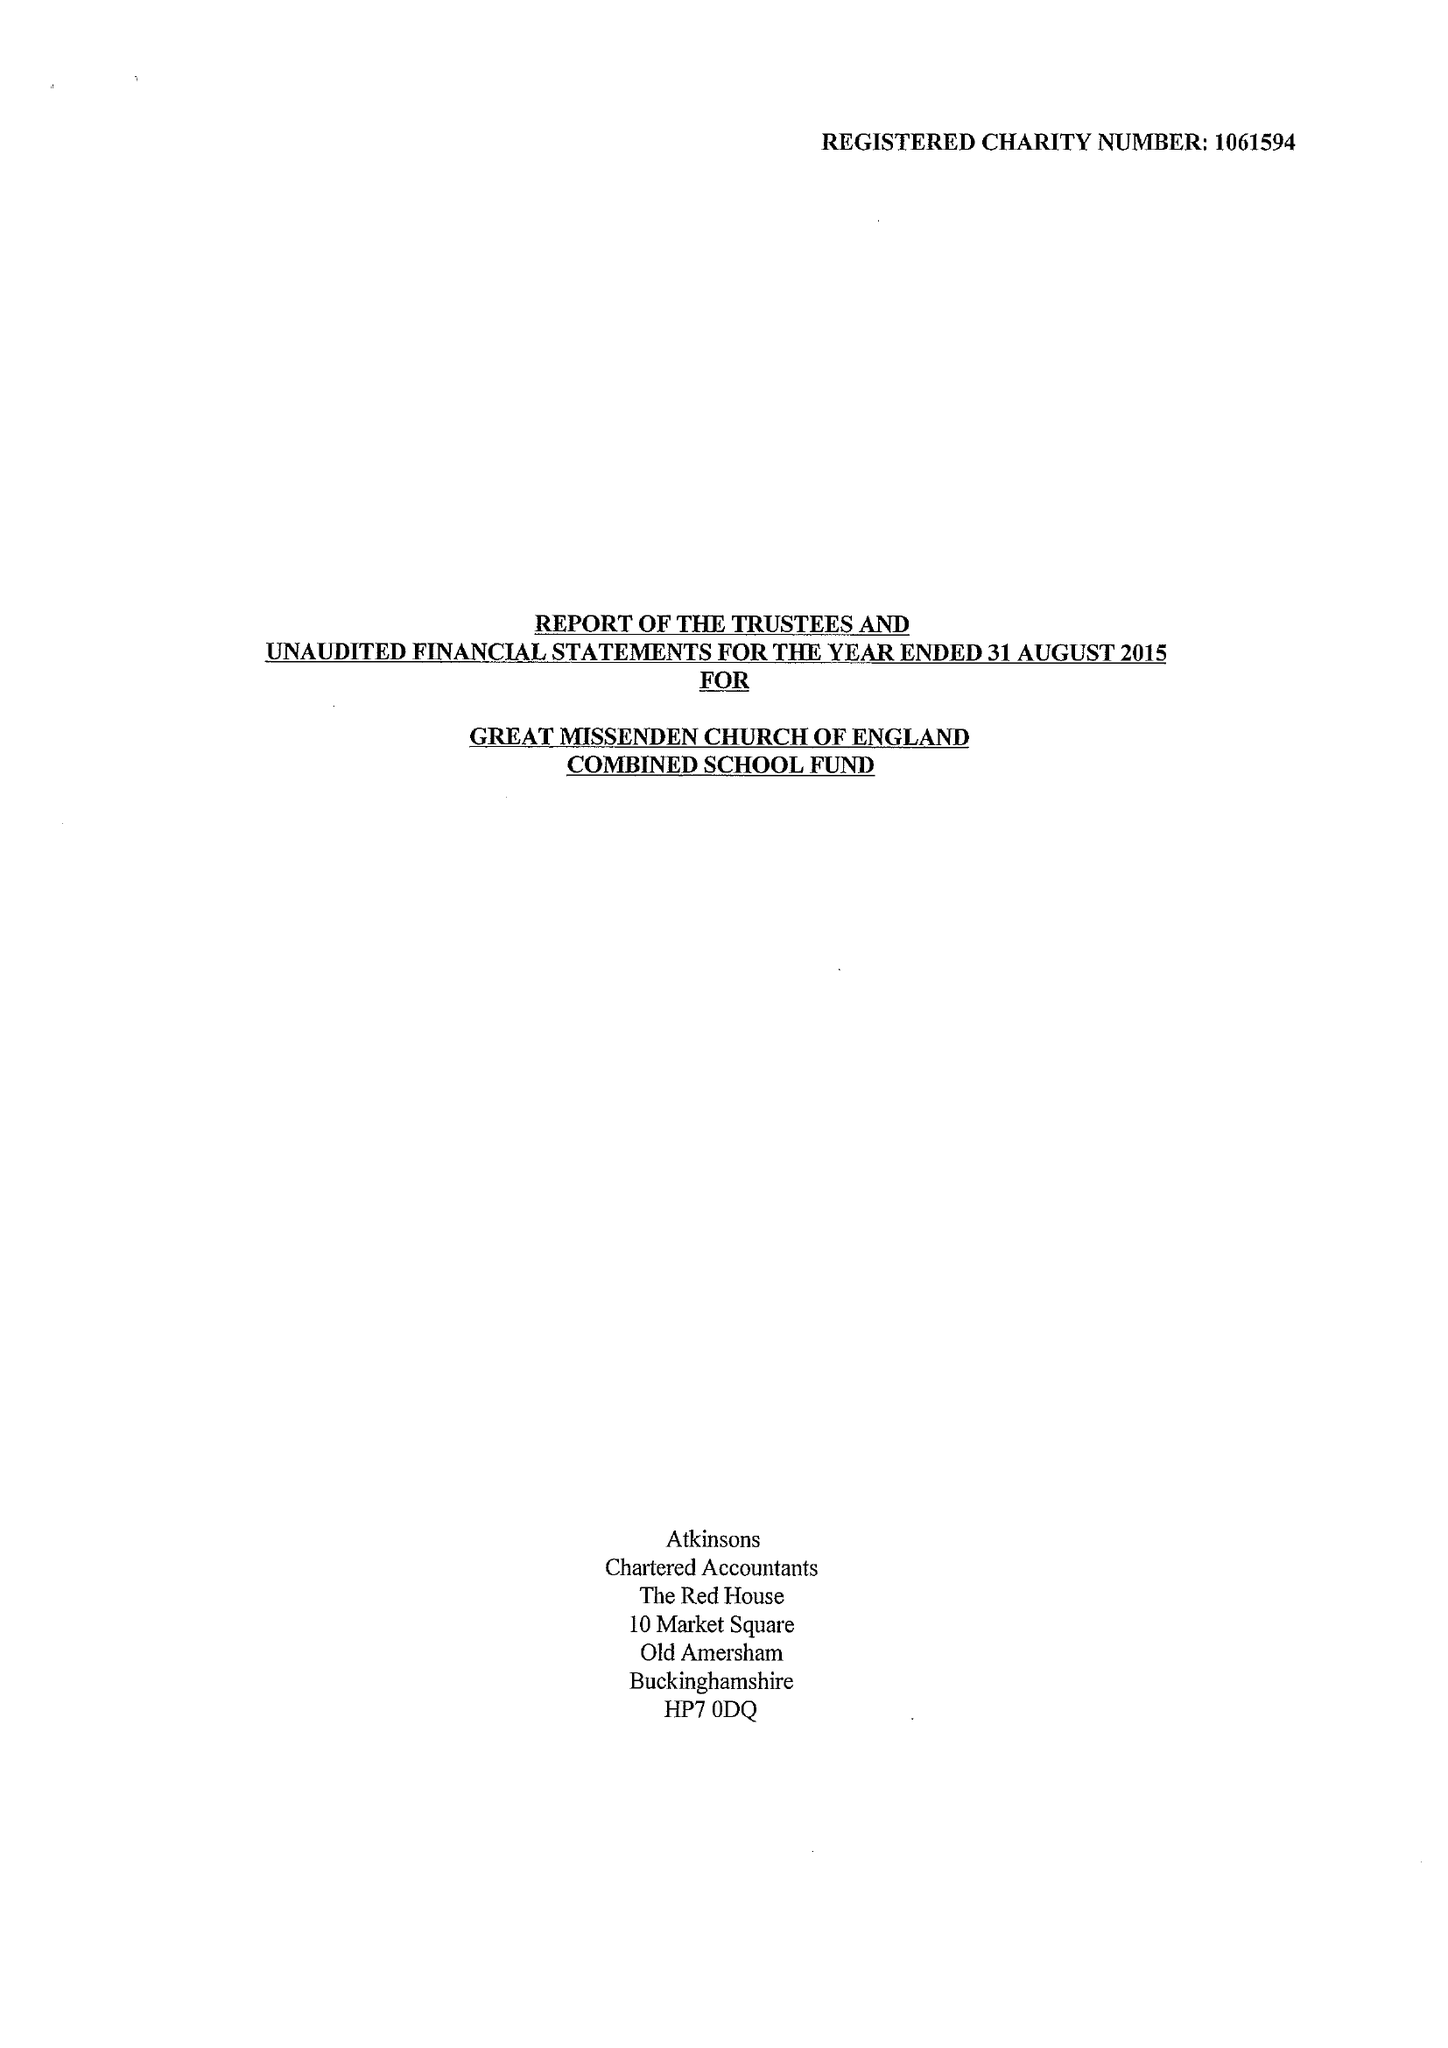What is the value for the address__postcode?
Answer the question using a single word or phrase. HP16 0AZ 